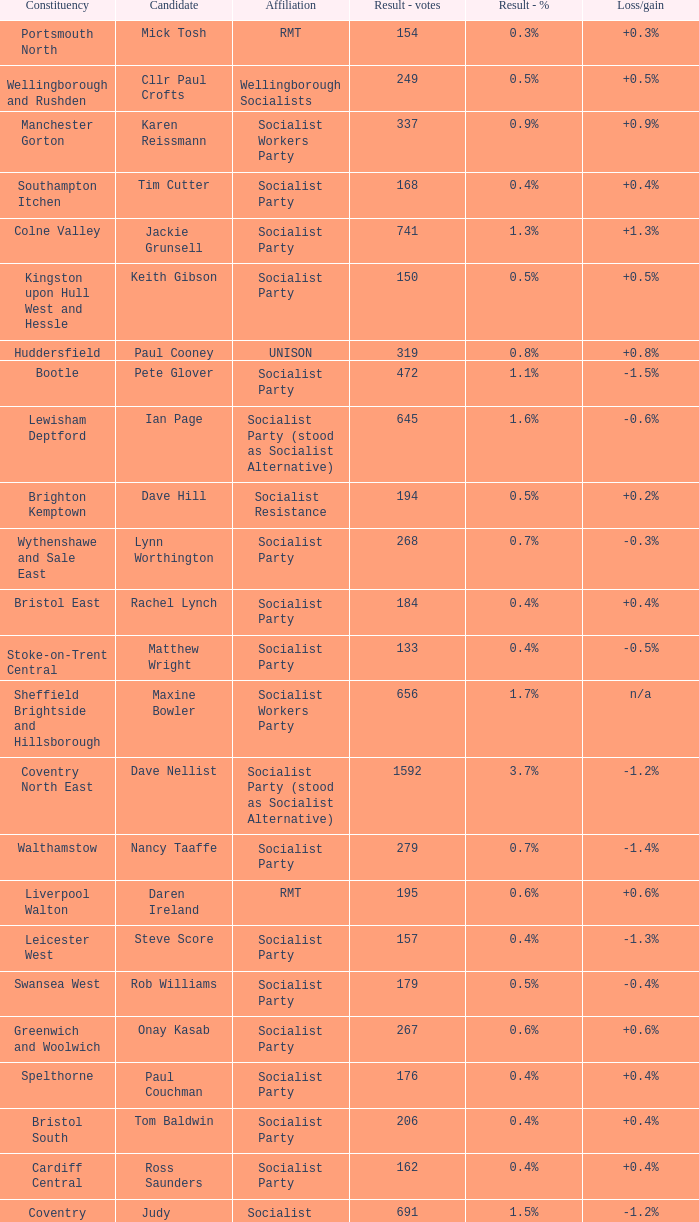What is the largest vote result if loss/gain is -0.5%? 133.0. Can you parse all the data within this table? {'header': ['Constituency', 'Candidate', 'Affiliation', 'Result - votes', 'Result - %', 'Loss/gain'], 'rows': [['Portsmouth North', 'Mick Tosh', 'RMT', '154', '0.3%', '+0.3%'], ['Wellingborough and Rushden', 'Cllr Paul Crofts', 'Wellingborough Socialists', '249', '0.5%', '+0.5%'], ['Manchester Gorton', 'Karen Reissmann', 'Socialist Workers Party', '337', '0.9%', '+0.9%'], ['Southampton Itchen', 'Tim Cutter', 'Socialist Party', '168', '0.4%', '+0.4%'], ['Colne Valley', 'Jackie Grunsell', 'Socialist Party', '741', '1.3%', '+1.3%'], ['Kingston upon Hull West and Hessle', 'Keith Gibson', 'Socialist Party', '150', '0.5%', '+0.5%'], ['Huddersfield', 'Paul Cooney', 'UNISON', '319', '0.8%', '+0.8%'], ['Bootle', 'Pete Glover', 'Socialist Party', '472', '1.1%', '-1.5%'], ['Lewisham Deptford', 'Ian Page', 'Socialist Party (stood as Socialist Alternative)', '645', '1.6%', '-0.6%'], ['Brighton Kemptown', 'Dave Hill', 'Socialist Resistance', '194', '0.5%', '+0.2%'], ['Wythenshawe and Sale East', 'Lynn Worthington', 'Socialist Party', '268', '0.7%', '-0.3%'], ['Bristol East', 'Rachel Lynch', 'Socialist Party', '184', '0.4%', '+0.4%'], ['Stoke-on-Trent Central', 'Matthew Wright', 'Socialist Party', '133', '0.4%', '-0.5%'], ['Sheffield Brightside and Hillsborough', 'Maxine Bowler', 'Socialist Workers Party', '656', '1.7%', 'n/a'], ['Coventry North East', 'Dave Nellist', 'Socialist Party (stood as Socialist Alternative)', '1592', '3.7%', '-1.2%'], ['Walthamstow', 'Nancy Taaffe', 'Socialist Party', '279', '0.7%', '-1.4%'], ['Liverpool Walton', 'Daren Ireland', 'RMT', '195', '0.6%', '+0.6%'], ['Leicester West', 'Steve Score', 'Socialist Party', '157', '0.4%', '-1.3%'], ['Swansea West', 'Rob Williams', 'Socialist Party', '179', '0.5%', '-0.4%'], ['Greenwich and Woolwich', 'Onay Kasab', 'Socialist Party', '267', '0.6%', '+0.6%'], ['Spelthorne', 'Paul Couchman', 'Socialist Party', '176', '0.4%', '+0.4%'], ['Bristol South', 'Tom Baldwin', 'Socialist Party', '206', '0.4%', '+0.4%'], ['Cardiff Central', 'Ross Saunders', 'Socialist Party', '162', '0.4%', '+0.4%'], ['Coventry South', 'Judy Griffiths', 'Socialist Party (stood as Socialist Alternative)', '691', '1.5%', '-1.2%'], ['Doncaster North', 'Bill Rawcliffe', 'RMT', '181', '0.4%', '+0.4%'], ['Carlisle', 'John Metcalfe', 'Communist Party of Britain', '376', '0.9%', 'n/a'], ['Gateshead', 'Elaine Brunskill', 'Socialist Party', '266', '0.7%', 'n/a'], ['Tottenham', 'Jenny Sutton', 'UCU', '1057', '2.6%', '+2.6%'], ['Coventry North West', 'Nicky Downes', 'Socialist Party (stood as Socialist Alternative)', '370', '0.8%', '-0.7%'], ['Salford & Eccles', 'David Henry', 'Green Left', '730', '1.8%', '+1.8%']]} 